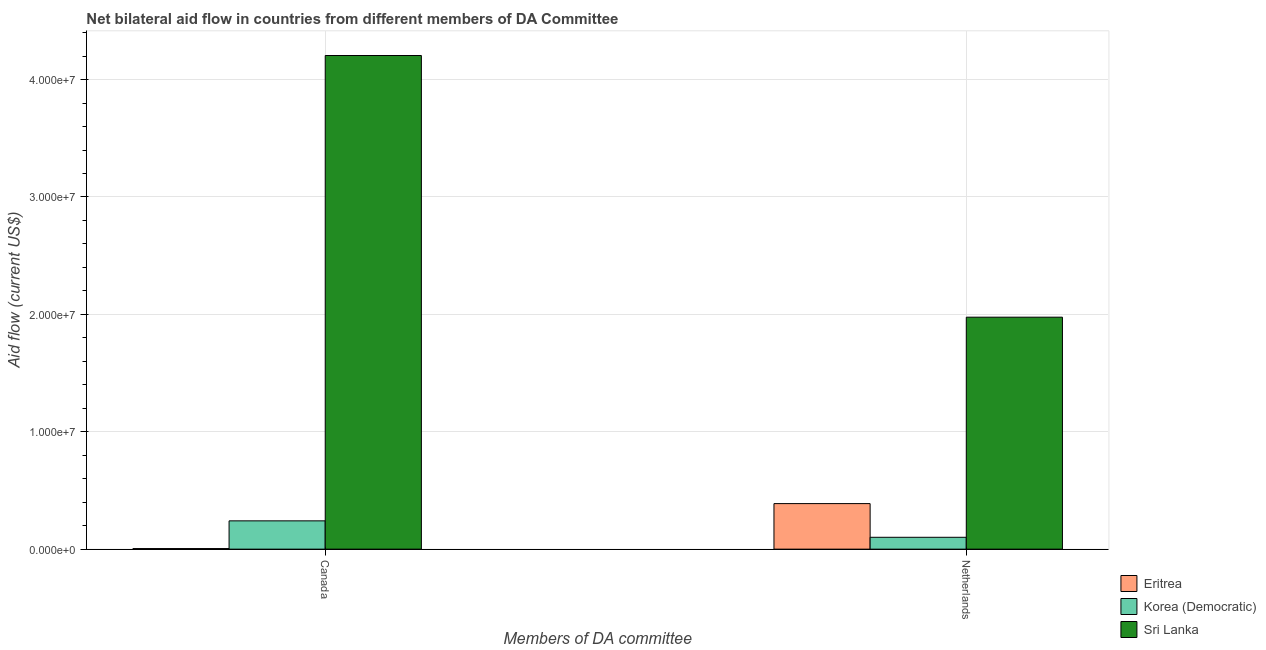How many different coloured bars are there?
Give a very brief answer. 3. How many groups of bars are there?
Make the answer very short. 2. How many bars are there on the 1st tick from the right?
Offer a very short reply. 3. What is the amount of aid given by netherlands in Korea (Democratic)?
Ensure brevity in your answer.  1.01e+06. Across all countries, what is the maximum amount of aid given by canada?
Provide a succinct answer. 4.20e+07. Across all countries, what is the minimum amount of aid given by netherlands?
Provide a succinct answer. 1.01e+06. In which country was the amount of aid given by netherlands maximum?
Offer a terse response. Sri Lanka. In which country was the amount of aid given by canada minimum?
Your response must be concise. Eritrea. What is the total amount of aid given by netherlands in the graph?
Keep it short and to the point. 2.46e+07. What is the difference between the amount of aid given by netherlands in Sri Lanka and that in Korea (Democratic)?
Provide a short and direct response. 1.88e+07. What is the difference between the amount of aid given by canada in Korea (Democratic) and the amount of aid given by netherlands in Sri Lanka?
Give a very brief answer. -1.74e+07. What is the average amount of aid given by netherlands per country?
Give a very brief answer. 8.22e+06. What is the difference between the amount of aid given by canada and amount of aid given by netherlands in Korea (Democratic)?
Offer a terse response. 1.40e+06. In how many countries, is the amount of aid given by netherlands greater than 42000000 US$?
Your answer should be compact. 0. What is the ratio of the amount of aid given by canada in Eritrea to that in Sri Lanka?
Your answer should be very brief. 0. Is the amount of aid given by netherlands in Sri Lanka less than that in Korea (Democratic)?
Offer a terse response. No. What does the 1st bar from the left in Netherlands represents?
Keep it short and to the point. Eritrea. What does the 1st bar from the right in Canada represents?
Make the answer very short. Sri Lanka. Does the graph contain any zero values?
Give a very brief answer. No. Where does the legend appear in the graph?
Offer a terse response. Bottom right. How many legend labels are there?
Provide a short and direct response. 3. How are the legend labels stacked?
Keep it short and to the point. Vertical. What is the title of the graph?
Ensure brevity in your answer.  Net bilateral aid flow in countries from different members of DA Committee. Does "Croatia" appear as one of the legend labels in the graph?
Your response must be concise. No. What is the label or title of the X-axis?
Keep it short and to the point. Members of DA committee. What is the Aid flow (current US$) of Eritrea in Canada?
Offer a terse response. 5.00e+04. What is the Aid flow (current US$) in Korea (Democratic) in Canada?
Provide a succinct answer. 2.41e+06. What is the Aid flow (current US$) in Sri Lanka in Canada?
Offer a very short reply. 4.20e+07. What is the Aid flow (current US$) in Eritrea in Netherlands?
Your response must be concise. 3.88e+06. What is the Aid flow (current US$) of Korea (Democratic) in Netherlands?
Offer a very short reply. 1.01e+06. What is the Aid flow (current US$) in Sri Lanka in Netherlands?
Offer a very short reply. 1.98e+07. Across all Members of DA committee, what is the maximum Aid flow (current US$) in Eritrea?
Offer a very short reply. 3.88e+06. Across all Members of DA committee, what is the maximum Aid flow (current US$) in Korea (Democratic)?
Keep it short and to the point. 2.41e+06. Across all Members of DA committee, what is the maximum Aid flow (current US$) of Sri Lanka?
Your answer should be very brief. 4.20e+07. Across all Members of DA committee, what is the minimum Aid flow (current US$) of Eritrea?
Provide a short and direct response. 5.00e+04. Across all Members of DA committee, what is the minimum Aid flow (current US$) in Korea (Democratic)?
Offer a terse response. 1.01e+06. Across all Members of DA committee, what is the minimum Aid flow (current US$) in Sri Lanka?
Provide a succinct answer. 1.98e+07. What is the total Aid flow (current US$) of Eritrea in the graph?
Your response must be concise. 3.93e+06. What is the total Aid flow (current US$) in Korea (Democratic) in the graph?
Ensure brevity in your answer.  3.42e+06. What is the total Aid flow (current US$) in Sri Lanka in the graph?
Ensure brevity in your answer.  6.18e+07. What is the difference between the Aid flow (current US$) of Eritrea in Canada and that in Netherlands?
Ensure brevity in your answer.  -3.83e+06. What is the difference between the Aid flow (current US$) in Korea (Democratic) in Canada and that in Netherlands?
Provide a short and direct response. 1.40e+06. What is the difference between the Aid flow (current US$) of Sri Lanka in Canada and that in Netherlands?
Give a very brief answer. 2.23e+07. What is the difference between the Aid flow (current US$) of Eritrea in Canada and the Aid flow (current US$) of Korea (Democratic) in Netherlands?
Your answer should be very brief. -9.60e+05. What is the difference between the Aid flow (current US$) of Eritrea in Canada and the Aid flow (current US$) of Sri Lanka in Netherlands?
Your answer should be very brief. -1.97e+07. What is the difference between the Aid flow (current US$) in Korea (Democratic) in Canada and the Aid flow (current US$) in Sri Lanka in Netherlands?
Ensure brevity in your answer.  -1.74e+07. What is the average Aid flow (current US$) of Eritrea per Members of DA committee?
Provide a succinct answer. 1.96e+06. What is the average Aid flow (current US$) in Korea (Democratic) per Members of DA committee?
Provide a short and direct response. 1.71e+06. What is the average Aid flow (current US$) in Sri Lanka per Members of DA committee?
Offer a very short reply. 3.09e+07. What is the difference between the Aid flow (current US$) in Eritrea and Aid flow (current US$) in Korea (Democratic) in Canada?
Give a very brief answer. -2.36e+06. What is the difference between the Aid flow (current US$) in Eritrea and Aid flow (current US$) in Sri Lanka in Canada?
Ensure brevity in your answer.  -4.20e+07. What is the difference between the Aid flow (current US$) in Korea (Democratic) and Aid flow (current US$) in Sri Lanka in Canada?
Ensure brevity in your answer.  -3.96e+07. What is the difference between the Aid flow (current US$) of Eritrea and Aid flow (current US$) of Korea (Democratic) in Netherlands?
Your response must be concise. 2.87e+06. What is the difference between the Aid flow (current US$) in Eritrea and Aid flow (current US$) in Sri Lanka in Netherlands?
Offer a terse response. -1.59e+07. What is the difference between the Aid flow (current US$) in Korea (Democratic) and Aid flow (current US$) in Sri Lanka in Netherlands?
Your answer should be very brief. -1.88e+07. What is the ratio of the Aid flow (current US$) in Eritrea in Canada to that in Netherlands?
Make the answer very short. 0.01. What is the ratio of the Aid flow (current US$) of Korea (Democratic) in Canada to that in Netherlands?
Provide a short and direct response. 2.39. What is the ratio of the Aid flow (current US$) in Sri Lanka in Canada to that in Netherlands?
Offer a terse response. 2.13. What is the difference between the highest and the second highest Aid flow (current US$) in Eritrea?
Give a very brief answer. 3.83e+06. What is the difference between the highest and the second highest Aid flow (current US$) of Korea (Democratic)?
Provide a succinct answer. 1.40e+06. What is the difference between the highest and the second highest Aid flow (current US$) in Sri Lanka?
Make the answer very short. 2.23e+07. What is the difference between the highest and the lowest Aid flow (current US$) of Eritrea?
Provide a succinct answer. 3.83e+06. What is the difference between the highest and the lowest Aid flow (current US$) of Korea (Democratic)?
Make the answer very short. 1.40e+06. What is the difference between the highest and the lowest Aid flow (current US$) in Sri Lanka?
Offer a very short reply. 2.23e+07. 